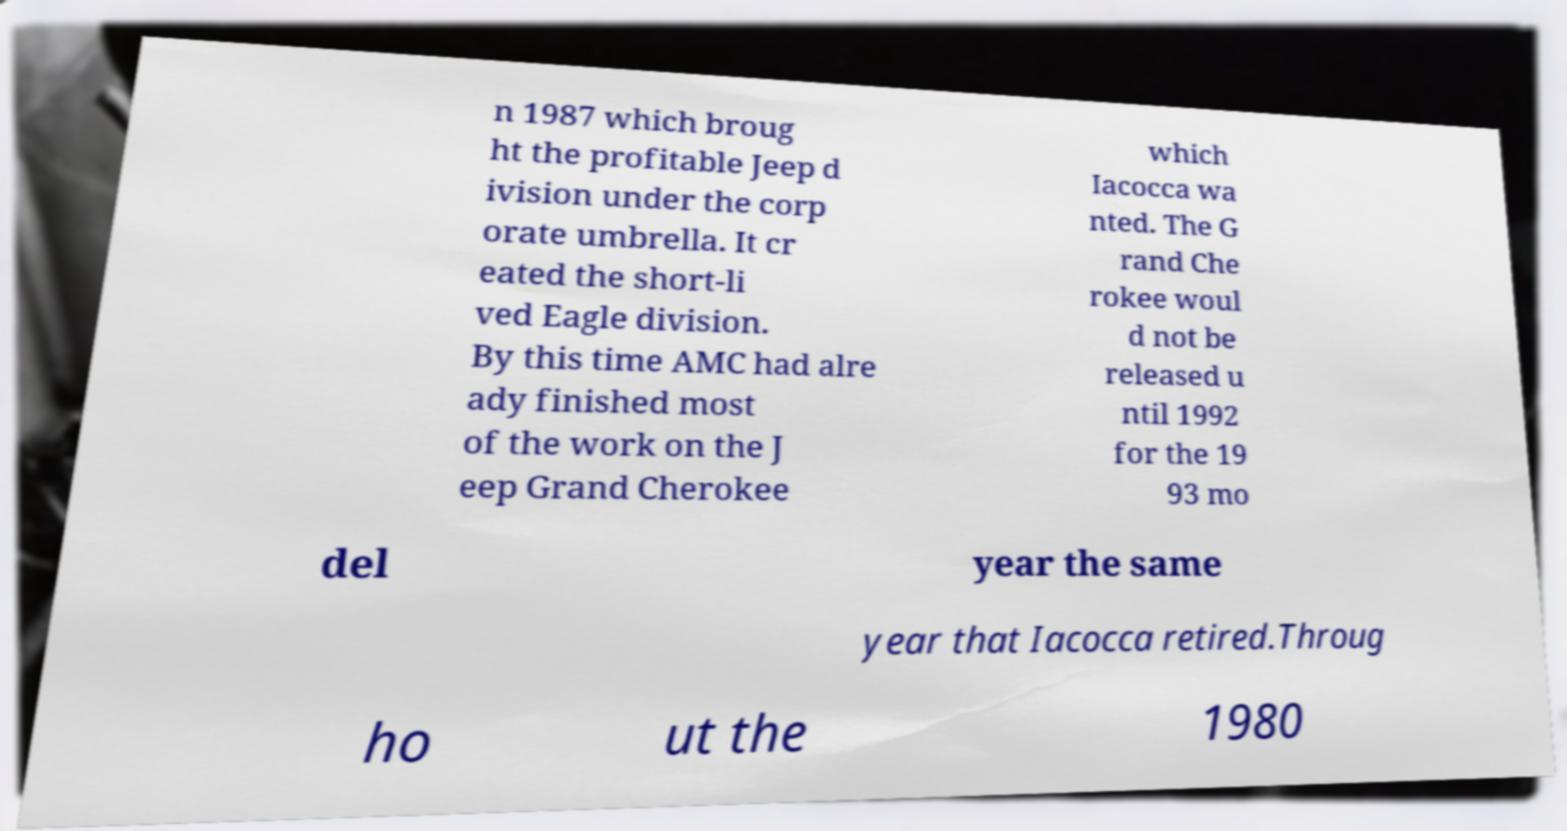For documentation purposes, I need the text within this image transcribed. Could you provide that? n 1987 which broug ht the profitable Jeep d ivision under the corp orate umbrella. It cr eated the short-li ved Eagle division. By this time AMC had alre ady finished most of the work on the J eep Grand Cherokee which Iacocca wa nted. The G rand Che rokee woul d not be released u ntil 1992 for the 19 93 mo del year the same year that Iacocca retired.Throug ho ut the 1980 